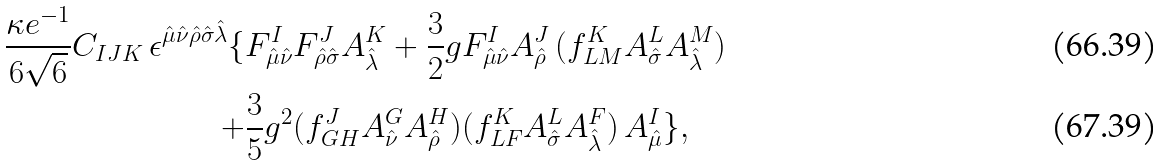Convert formula to latex. <formula><loc_0><loc_0><loc_500><loc_500>\frac { \kappa e ^ { - 1 } } { 6 \sqrt { 6 } } C _ { I J K } \, \epsilon ^ { \hat { \mu } \hat { \nu } \hat { \rho } \hat { \sigma } \hat { \lambda } } \{ & F ^ { I } _ { \hat { \mu } \hat { \nu } } F ^ { J } _ { \hat { \rho } \hat { \sigma } } A ^ { K } _ { \hat { \lambda } } + \frac { 3 } { 2 } g F ^ { I } _ { \hat { \mu } \hat { \nu } } A ^ { J } _ { \hat { \rho } } \, ( f ^ { K } _ { L M } A ^ { L } _ { \hat { \sigma } } A ^ { M } _ { \hat { \lambda } } ) \\ + & \frac { 3 } { 5 } g ^ { 2 } ( f ^ { J } _ { G H } A ^ { G } _ { \hat { \nu } } A ^ { H } _ { \hat { \rho } } ) ( f ^ { K } _ { L F } A ^ { L } _ { \hat { \sigma } } A ^ { F } _ { \hat { \lambda } } ) \, A ^ { I } _ { \hat { \mu } } \} ,</formula> 